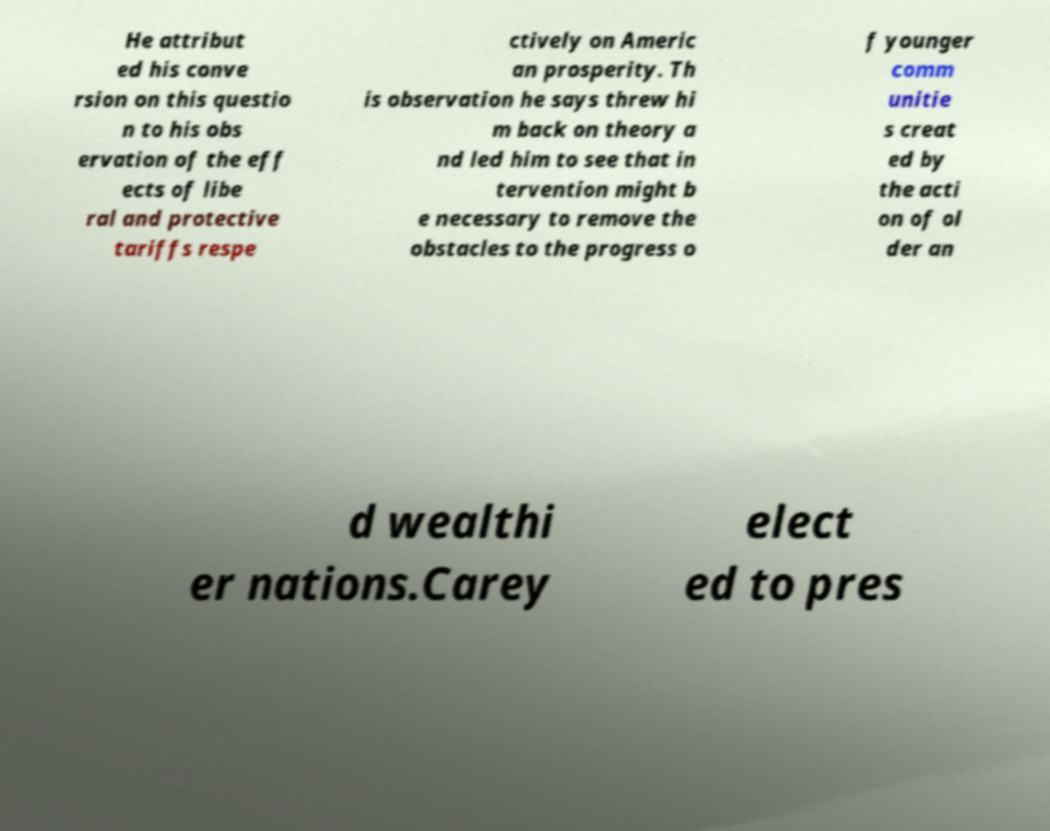Please identify and transcribe the text found in this image. He attribut ed his conve rsion on this questio n to his obs ervation of the eff ects of libe ral and protective tariffs respe ctively on Americ an prosperity. Th is observation he says threw hi m back on theory a nd led him to see that in tervention might b e necessary to remove the obstacles to the progress o f younger comm unitie s creat ed by the acti on of ol der an d wealthi er nations.Carey elect ed to pres 